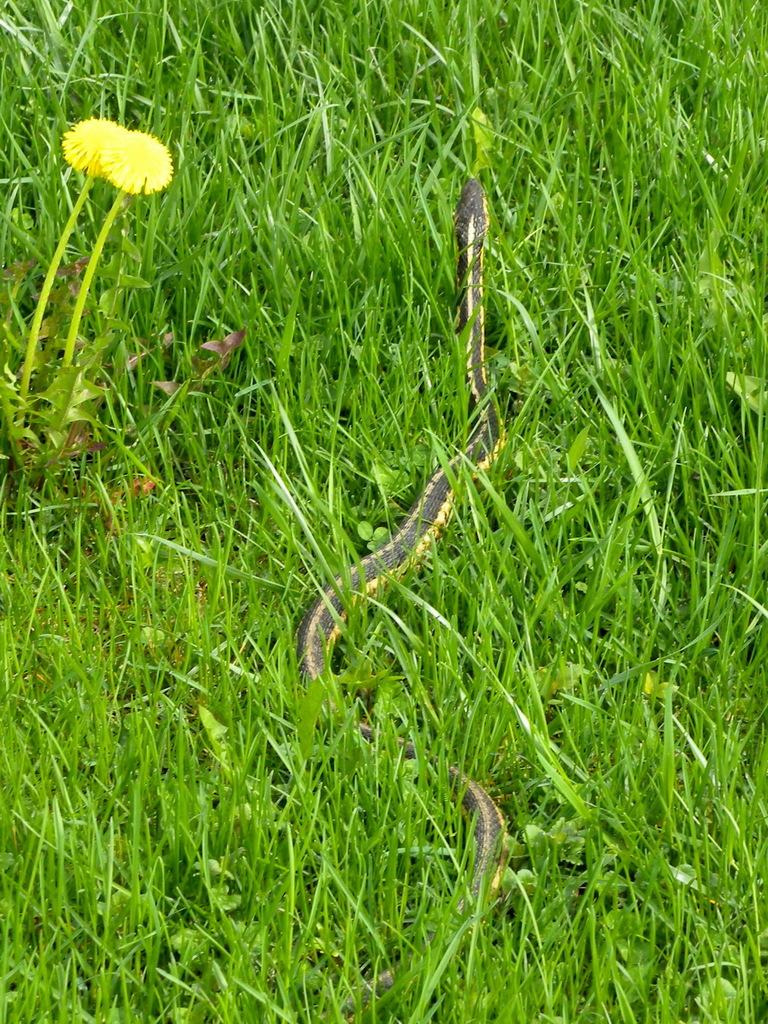What is the main subject in the center of the image? There is a snake in the center of the image. What type of environment is depicted in the image? There is grassland surrounding the area in the image. What can be seen on the left side of the image? There are flowers on the left side of the image. What type of chess pieces can be seen on the grassland in the image? There are no chess pieces present in the image; it features a snake and flowers in a grassland environment. How many bells are hanging from the snake in the image? There are no bells present in the image; it features a snake and flowers in a grassland environment. 